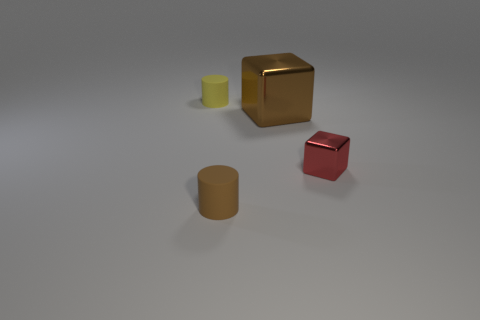Are there any other things that have the same size as the brown block?
Make the answer very short. No. Do the tiny rubber cylinder that is to the right of the small yellow rubber cylinder and the cylinder that is behind the small red block have the same color?
Provide a short and direct response. No. What number of other objects are there of the same size as the red thing?
Ensure brevity in your answer.  2. Are there any small red cubes that are behind the tiny object on the left side of the matte cylinder in front of the small yellow rubber object?
Give a very brief answer. No. Does the small cylinder that is to the right of the yellow matte thing have the same material as the tiny yellow cylinder?
Offer a terse response. Yes. There is another small matte object that is the same shape as the yellow thing; what is its color?
Give a very brief answer. Brown. Is there any other thing that has the same shape as the tiny brown matte thing?
Your response must be concise. Yes. Is the number of yellow things that are to the left of the yellow thing the same as the number of cyan things?
Provide a succinct answer. Yes. There is a small red object; are there any tiny shiny blocks in front of it?
Make the answer very short. No. There is a rubber cylinder that is on the right side of the matte cylinder that is behind the rubber object that is right of the small yellow rubber cylinder; what size is it?
Provide a short and direct response. Small. 